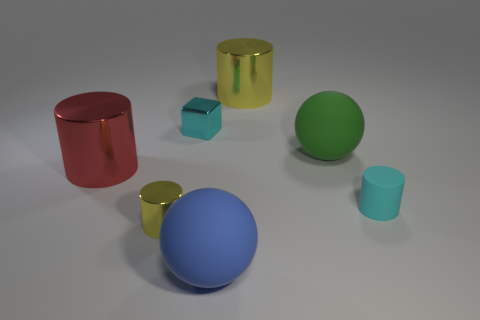Subtract all cyan matte cylinders. How many cylinders are left? 3 Add 2 brown cylinders. How many objects exist? 9 Subtract all blocks. How many objects are left? 6 Subtract 1 cylinders. How many cylinders are left? 3 Subtract all yellow cylinders. How many cylinders are left? 2 Subtract all green cylinders. How many green blocks are left? 0 Subtract all large green cylinders. Subtract all large green spheres. How many objects are left? 6 Add 4 large green matte spheres. How many large green matte spheres are left? 5 Add 7 large brown balls. How many large brown balls exist? 7 Subtract 1 cyan cylinders. How many objects are left? 6 